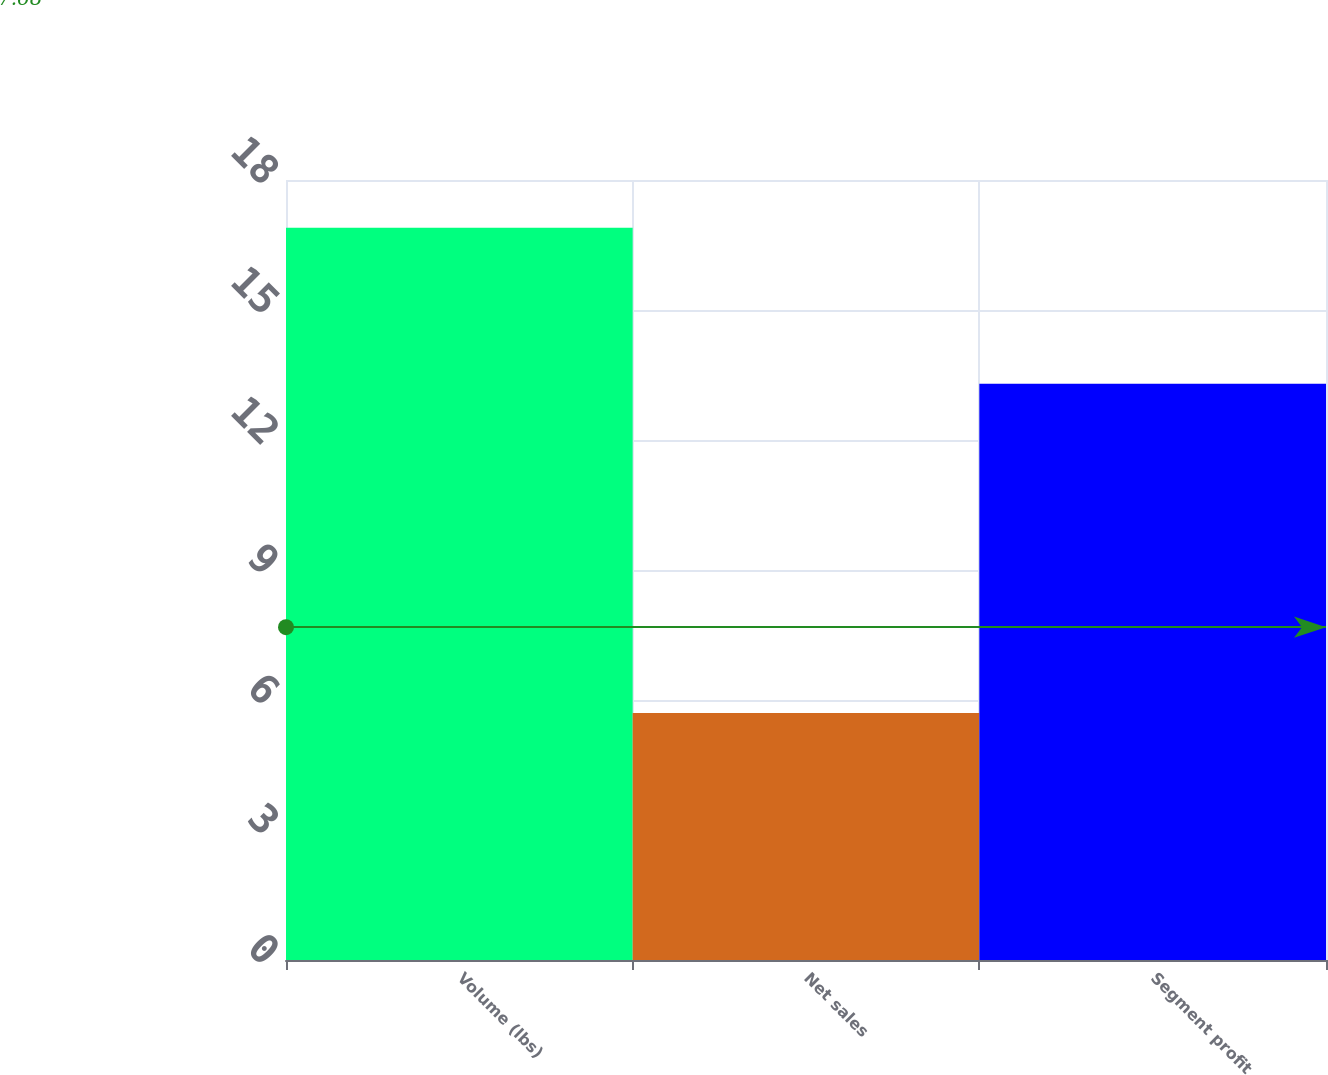Convert chart. <chart><loc_0><loc_0><loc_500><loc_500><bar_chart><fcel>Volume (lbs)<fcel>Net sales<fcel>Segment profit<nl><fcel>16.9<fcel>5.7<fcel>13.3<nl></chart> 